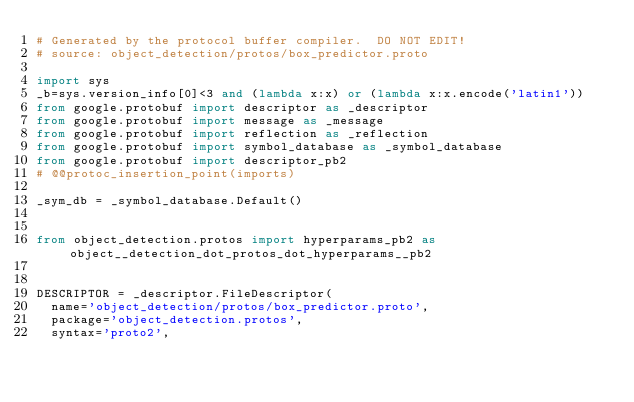<code> <loc_0><loc_0><loc_500><loc_500><_Python_># Generated by the protocol buffer compiler.  DO NOT EDIT!
# source: object_detection/protos/box_predictor.proto

import sys
_b=sys.version_info[0]<3 and (lambda x:x) or (lambda x:x.encode('latin1'))
from google.protobuf import descriptor as _descriptor
from google.protobuf import message as _message
from google.protobuf import reflection as _reflection
from google.protobuf import symbol_database as _symbol_database
from google.protobuf import descriptor_pb2
# @@protoc_insertion_point(imports)

_sym_db = _symbol_database.Default()


from object_detection.protos import hyperparams_pb2 as object__detection_dot_protos_dot_hyperparams__pb2


DESCRIPTOR = _descriptor.FileDescriptor(
  name='object_detection/protos/box_predictor.proto',
  package='object_detection.protos',
  syntax='proto2',</code> 